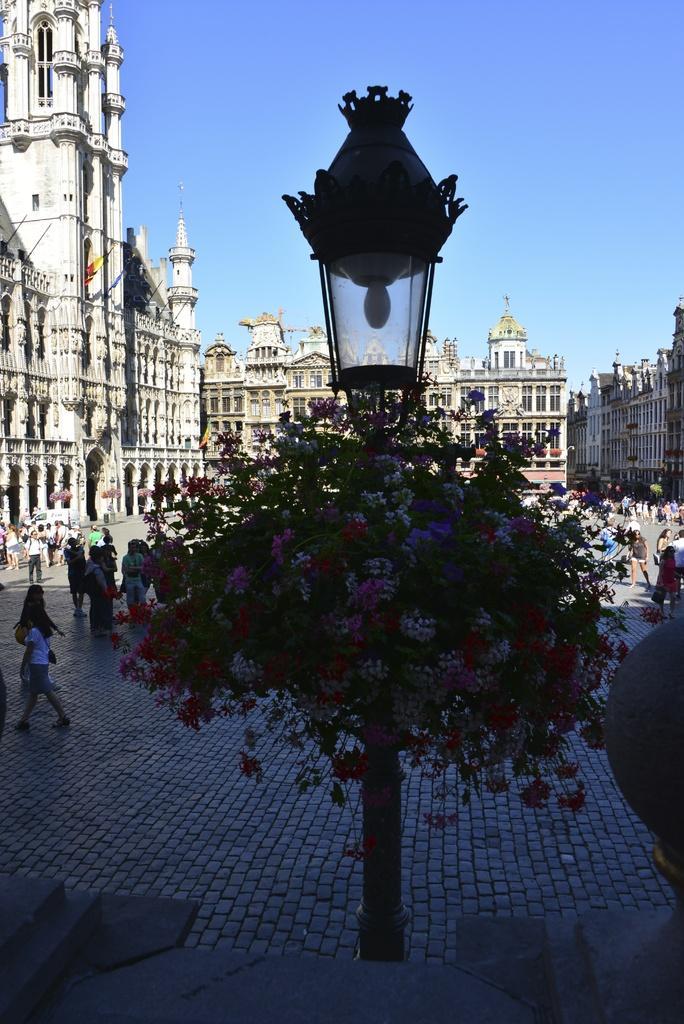In one or two sentences, can you explain what this image depicts? In this image we can see some buildings at the background, some people in front of the building and there is a light with pink and white flowers with green leaves. 